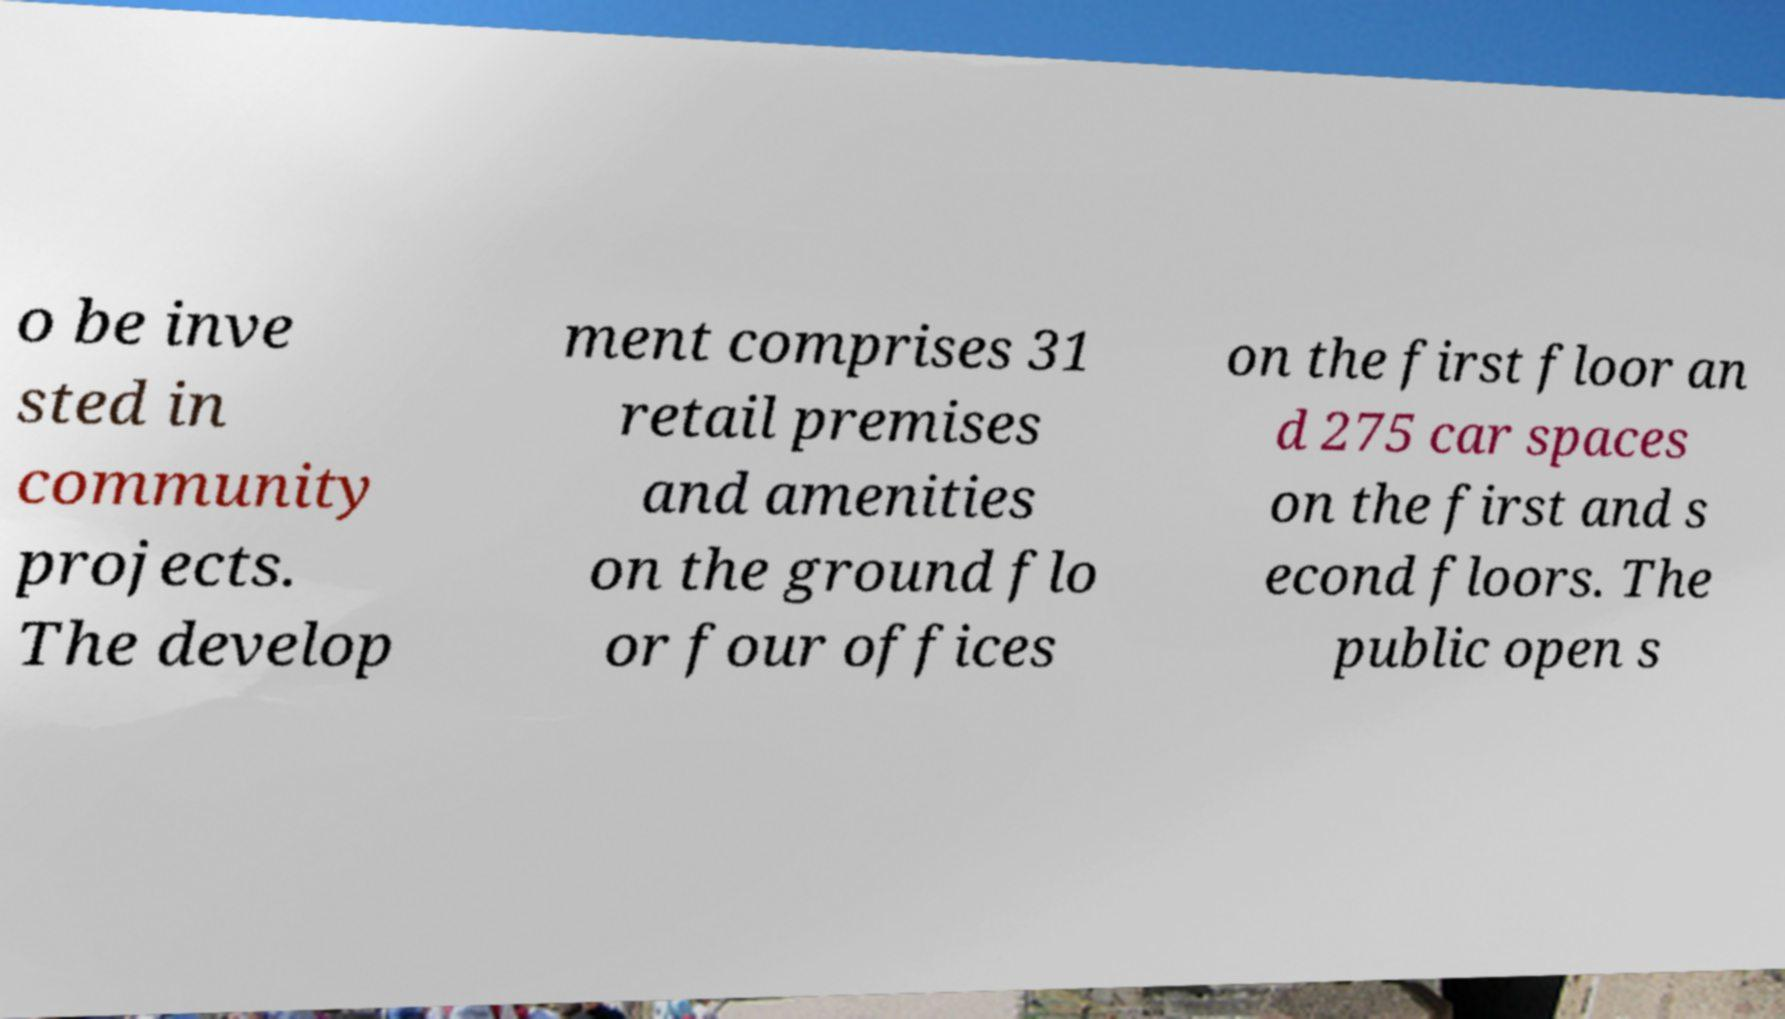Can you accurately transcribe the text from the provided image for me? o be inve sted in community projects. The develop ment comprises 31 retail premises and amenities on the ground flo or four offices on the first floor an d 275 car spaces on the first and s econd floors. The public open s 